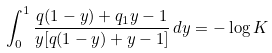<formula> <loc_0><loc_0><loc_500><loc_500>\int _ { 0 } ^ { 1 } \frac { q ( 1 - y ) + q _ { 1 } y - 1 } { y [ q ( 1 - y ) + y - 1 ] } \, d y = - \log K</formula> 